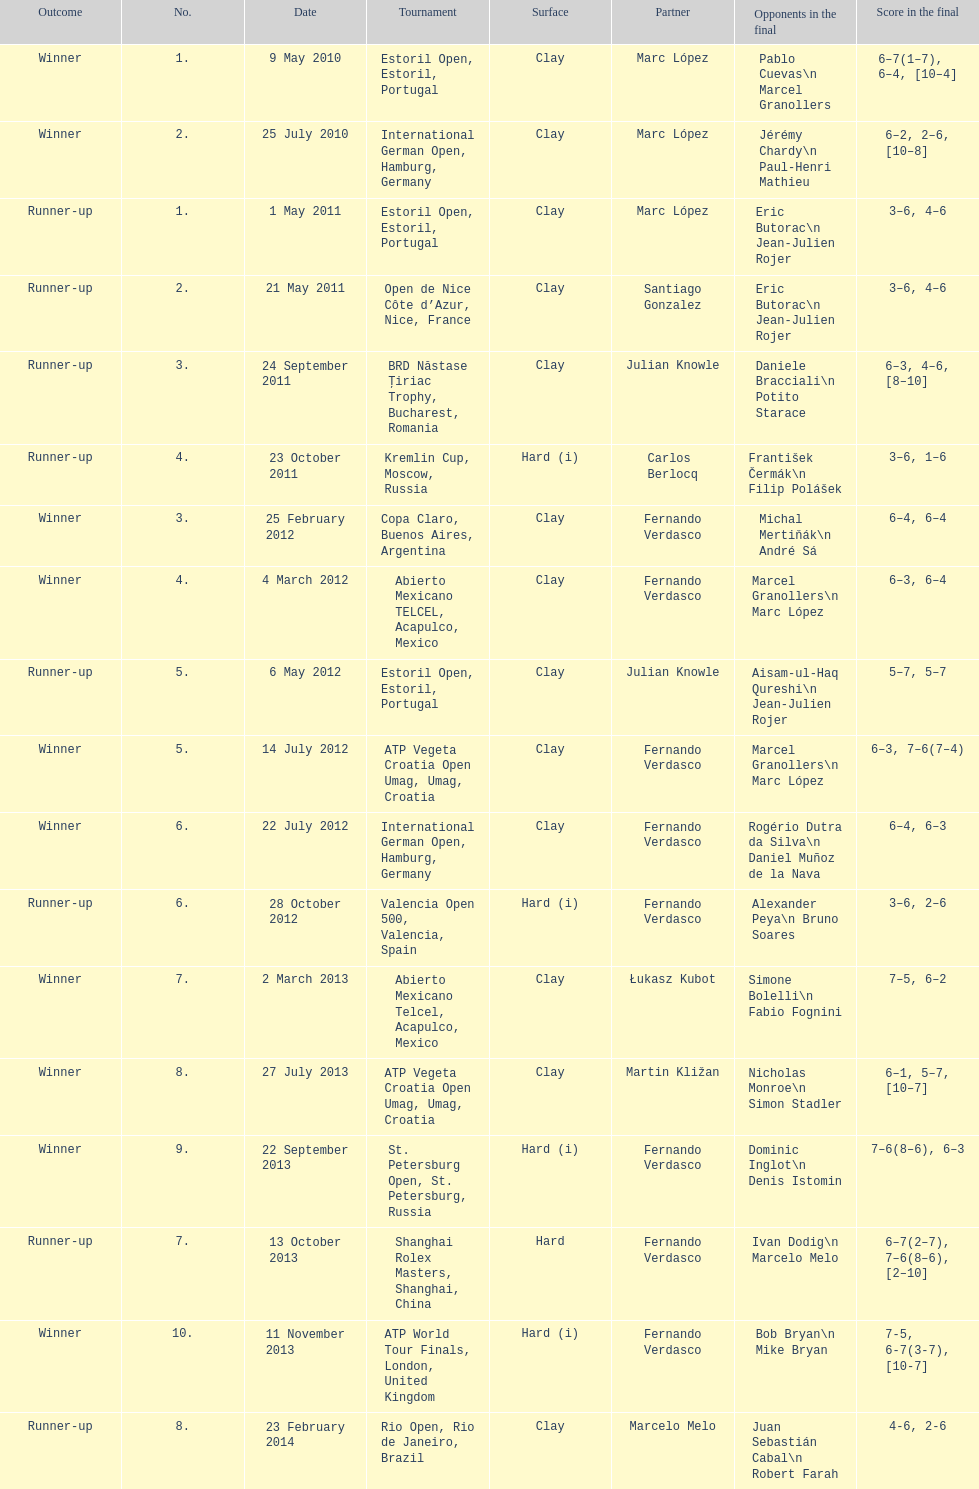Who won both the st.petersburg open and the atp world tour finals? Fernando Verdasco. 